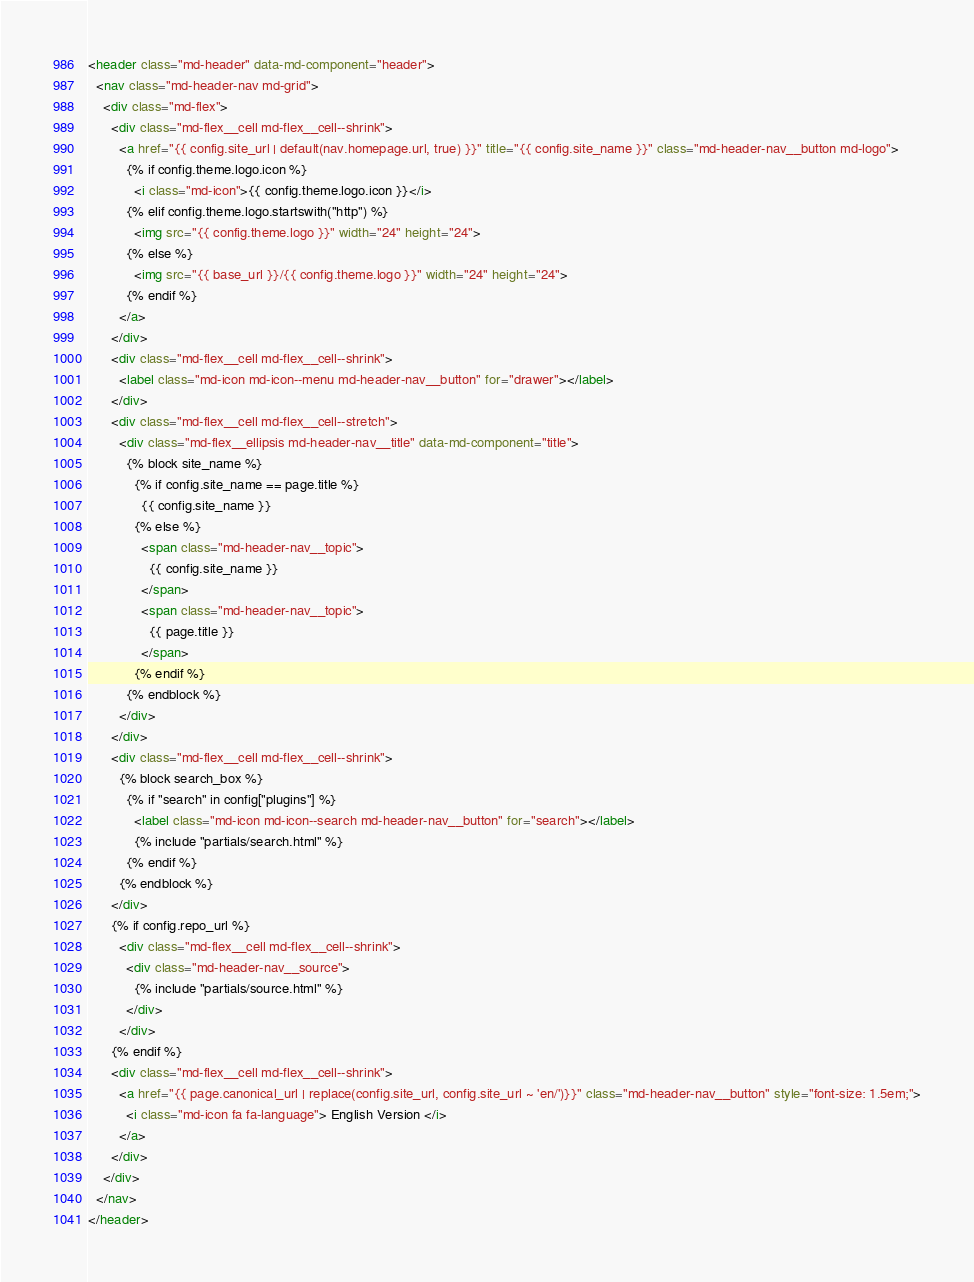Convert code to text. <code><loc_0><loc_0><loc_500><loc_500><_HTML_><header class="md-header" data-md-component="header">
  <nav class="md-header-nav md-grid">
    <div class="md-flex">
      <div class="md-flex__cell md-flex__cell--shrink">
        <a href="{{ config.site_url | default(nav.homepage.url, true) }}" title="{{ config.site_name }}" class="md-header-nav__button md-logo">
          {% if config.theme.logo.icon %}
            <i class="md-icon">{{ config.theme.logo.icon }}</i>
          {% elif config.theme.logo.startswith("http") %}
            <img src="{{ config.theme.logo }}" width="24" height="24">
          {% else %}
            <img src="{{ base_url }}/{{ config.theme.logo }}" width="24" height="24">
          {% endif %}
        </a>
      </div>
      <div class="md-flex__cell md-flex__cell--shrink">
        <label class="md-icon md-icon--menu md-header-nav__button" for="drawer"></label>
      </div>
      <div class="md-flex__cell md-flex__cell--stretch">
        <div class="md-flex__ellipsis md-header-nav__title" data-md-component="title">
          {% block site_name %}
            {% if config.site_name == page.title %}
              {{ config.site_name }}
            {% else %}
              <span class="md-header-nav__topic">
                {{ config.site_name }}
              </span>
              <span class="md-header-nav__topic">
                {{ page.title }}
              </span>
            {% endif %}
          {% endblock %}
        </div>
      </div>
      <div class="md-flex__cell md-flex__cell--shrink">
        {% block search_box %}
          {% if "search" in config["plugins"] %}
            <label class="md-icon md-icon--search md-header-nav__button" for="search"></label>
            {% include "partials/search.html" %}
          {% endif %}
        {% endblock %}
      </div>
      {% if config.repo_url %}
        <div class="md-flex__cell md-flex__cell--shrink">
          <div class="md-header-nav__source">
            {% include "partials/source.html" %}
          </div>
        </div>
      {% endif %}
	  <div class="md-flex__cell md-flex__cell--shrink">
        <a href="{{ page.canonical_url | replace(config.site_url, config.site_url ~ 'en/')}}" class="md-header-nav__button" style="font-size: 1.5em;">
          <i class="md-icon fa fa-language"> English Version </i>
        </a>
      </div>
    </div>
  </nav>
</header>
</code> 